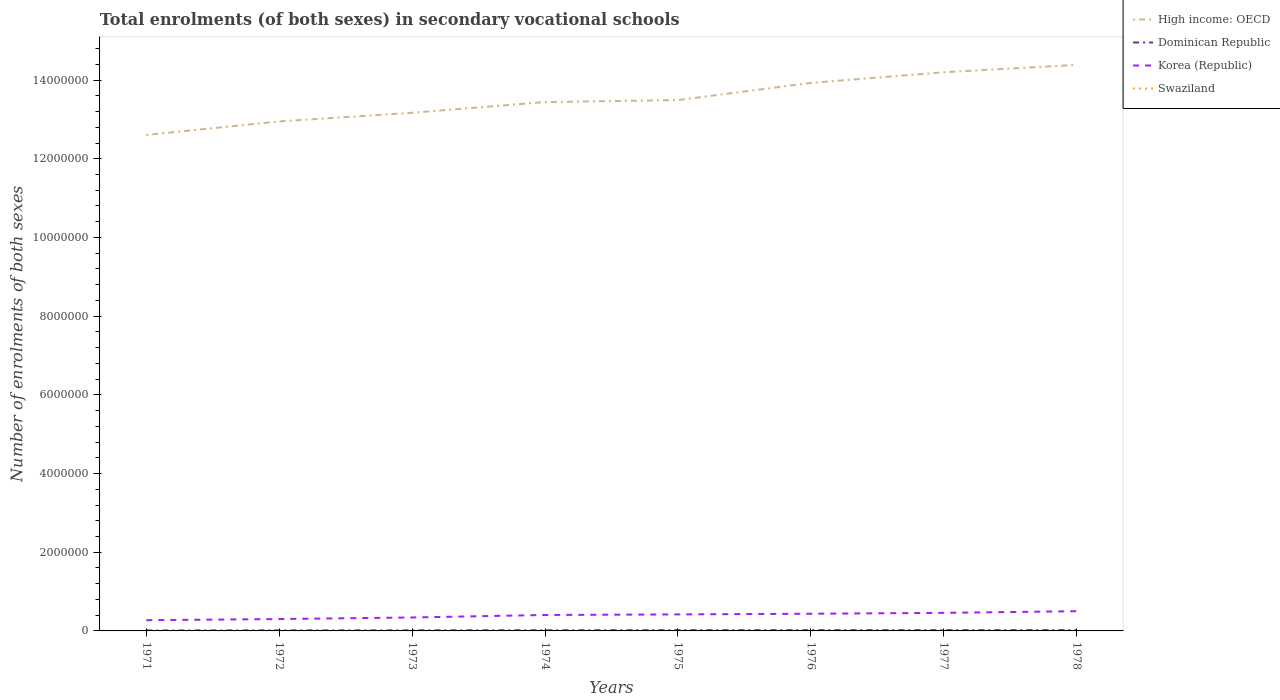Does the line corresponding to High income: OECD intersect with the line corresponding to Korea (Republic)?
Make the answer very short. No. Across all years, what is the maximum number of enrolments in secondary schools in Dominican Republic?
Your response must be concise. 1.26e+04. In which year was the number of enrolments in secondary schools in Swaziland maximum?
Offer a very short reply. 1977. What is the total number of enrolments in secondary schools in High income: OECD in the graph?
Give a very brief answer. -1.88e+05. What is the difference between the highest and the second highest number of enrolments in secondary schools in Dominican Republic?
Your answer should be compact. 8672. How many lines are there?
Offer a very short reply. 4. What is the difference between two consecutive major ticks on the Y-axis?
Your response must be concise. 2.00e+06. Does the graph contain any zero values?
Provide a succinct answer. No. Does the graph contain grids?
Your answer should be very brief. No. How many legend labels are there?
Keep it short and to the point. 4. How are the legend labels stacked?
Ensure brevity in your answer.  Vertical. What is the title of the graph?
Offer a terse response. Total enrolments (of both sexes) in secondary vocational schools. What is the label or title of the X-axis?
Keep it short and to the point. Years. What is the label or title of the Y-axis?
Make the answer very short. Number of enrolments of both sexes. What is the Number of enrolments of both sexes in High income: OECD in 1971?
Keep it short and to the point. 1.26e+07. What is the Number of enrolments of both sexes in Dominican Republic in 1971?
Your answer should be very brief. 1.26e+04. What is the Number of enrolments of both sexes in Korea (Republic) in 1971?
Offer a terse response. 2.73e+05. What is the Number of enrolments of both sexes in Swaziland in 1971?
Keep it short and to the point. 474. What is the Number of enrolments of both sexes of High income: OECD in 1972?
Offer a very short reply. 1.29e+07. What is the Number of enrolments of both sexes of Dominican Republic in 1972?
Give a very brief answer. 1.43e+04. What is the Number of enrolments of both sexes in Korea (Republic) in 1972?
Provide a short and direct response. 3.02e+05. What is the Number of enrolments of both sexes of Swaziland in 1972?
Provide a succinct answer. 538. What is the Number of enrolments of both sexes in High income: OECD in 1973?
Offer a very short reply. 1.32e+07. What is the Number of enrolments of both sexes in Dominican Republic in 1973?
Your answer should be very brief. 1.47e+04. What is the Number of enrolments of both sexes in Korea (Republic) in 1973?
Ensure brevity in your answer.  3.42e+05. What is the Number of enrolments of both sexes in Swaziland in 1973?
Ensure brevity in your answer.  584. What is the Number of enrolments of both sexes of High income: OECD in 1974?
Give a very brief answer. 1.34e+07. What is the Number of enrolments of both sexes in Dominican Republic in 1974?
Offer a terse response. 1.74e+04. What is the Number of enrolments of both sexes in Korea (Republic) in 1974?
Ensure brevity in your answer.  4.05e+05. What is the Number of enrolments of both sexes in Swaziland in 1974?
Keep it short and to the point. 663. What is the Number of enrolments of both sexes of High income: OECD in 1975?
Make the answer very short. 1.35e+07. What is the Number of enrolments of both sexes in Dominican Republic in 1975?
Your answer should be very brief. 1.99e+04. What is the Number of enrolments of both sexes in Korea (Republic) in 1975?
Offer a terse response. 4.20e+05. What is the Number of enrolments of both sexes in Swaziland in 1975?
Make the answer very short. 649. What is the Number of enrolments of both sexes of High income: OECD in 1976?
Make the answer very short. 1.39e+07. What is the Number of enrolments of both sexes of Dominican Republic in 1976?
Your response must be concise. 2.07e+04. What is the Number of enrolments of both sexes of Korea (Republic) in 1976?
Offer a terse response. 4.37e+05. What is the Number of enrolments of both sexes in Swaziland in 1976?
Your answer should be very brief. 472. What is the Number of enrolments of both sexes in High income: OECD in 1977?
Make the answer very short. 1.42e+07. What is the Number of enrolments of both sexes in Dominican Republic in 1977?
Your answer should be very brief. 2.11e+04. What is the Number of enrolments of both sexes of Korea (Republic) in 1977?
Ensure brevity in your answer.  4.59e+05. What is the Number of enrolments of both sexes in Swaziland in 1977?
Offer a terse response. 403. What is the Number of enrolments of both sexes of High income: OECD in 1978?
Your answer should be compact. 1.44e+07. What is the Number of enrolments of both sexes in Dominican Republic in 1978?
Make the answer very short. 2.13e+04. What is the Number of enrolments of both sexes of Korea (Republic) in 1978?
Provide a succinct answer. 5.01e+05. What is the Number of enrolments of both sexes in Swaziland in 1978?
Make the answer very short. 406. Across all years, what is the maximum Number of enrolments of both sexes in High income: OECD?
Provide a short and direct response. 1.44e+07. Across all years, what is the maximum Number of enrolments of both sexes in Dominican Republic?
Your answer should be very brief. 2.13e+04. Across all years, what is the maximum Number of enrolments of both sexes in Korea (Republic)?
Offer a terse response. 5.01e+05. Across all years, what is the maximum Number of enrolments of both sexes of Swaziland?
Ensure brevity in your answer.  663. Across all years, what is the minimum Number of enrolments of both sexes in High income: OECD?
Your answer should be very brief. 1.26e+07. Across all years, what is the minimum Number of enrolments of both sexes in Dominican Republic?
Your response must be concise. 1.26e+04. Across all years, what is the minimum Number of enrolments of both sexes of Korea (Republic)?
Provide a short and direct response. 2.73e+05. Across all years, what is the minimum Number of enrolments of both sexes of Swaziland?
Offer a terse response. 403. What is the total Number of enrolments of both sexes in High income: OECD in the graph?
Keep it short and to the point. 1.08e+08. What is the total Number of enrolments of both sexes of Dominican Republic in the graph?
Provide a short and direct response. 1.42e+05. What is the total Number of enrolments of both sexes in Korea (Republic) in the graph?
Ensure brevity in your answer.  3.14e+06. What is the total Number of enrolments of both sexes in Swaziland in the graph?
Your answer should be compact. 4189. What is the difference between the Number of enrolments of both sexes of High income: OECD in 1971 and that in 1972?
Your response must be concise. -3.44e+05. What is the difference between the Number of enrolments of both sexes of Dominican Republic in 1971 and that in 1972?
Ensure brevity in your answer.  -1627. What is the difference between the Number of enrolments of both sexes of Korea (Republic) in 1971 and that in 1972?
Your response must be concise. -2.92e+04. What is the difference between the Number of enrolments of both sexes in Swaziland in 1971 and that in 1972?
Your answer should be very brief. -64. What is the difference between the Number of enrolments of both sexes of High income: OECD in 1971 and that in 1973?
Your answer should be very brief. -5.64e+05. What is the difference between the Number of enrolments of both sexes in Dominican Republic in 1971 and that in 1973?
Provide a succinct answer. -2021. What is the difference between the Number of enrolments of both sexes of Korea (Republic) in 1971 and that in 1973?
Offer a terse response. -6.92e+04. What is the difference between the Number of enrolments of both sexes of Swaziland in 1971 and that in 1973?
Offer a very short reply. -110. What is the difference between the Number of enrolments of both sexes in High income: OECD in 1971 and that in 1974?
Offer a very short reply. -8.36e+05. What is the difference between the Number of enrolments of both sexes in Dominican Republic in 1971 and that in 1974?
Give a very brief answer. -4732. What is the difference between the Number of enrolments of both sexes of Korea (Republic) in 1971 and that in 1974?
Offer a very short reply. -1.32e+05. What is the difference between the Number of enrolments of both sexes of Swaziland in 1971 and that in 1974?
Give a very brief answer. -189. What is the difference between the Number of enrolments of both sexes in High income: OECD in 1971 and that in 1975?
Ensure brevity in your answer.  -8.86e+05. What is the difference between the Number of enrolments of both sexes of Dominican Republic in 1971 and that in 1975?
Your answer should be very brief. -7251. What is the difference between the Number of enrolments of both sexes in Korea (Republic) in 1971 and that in 1975?
Give a very brief answer. -1.47e+05. What is the difference between the Number of enrolments of both sexes in Swaziland in 1971 and that in 1975?
Offer a very short reply. -175. What is the difference between the Number of enrolments of both sexes in High income: OECD in 1971 and that in 1976?
Make the answer very short. -1.32e+06. What is the difference between the Number of enrolments of both sexes in Dominican Republic in 1971 and that in 1976?
Provide a succinct answer. -8064. What is the difference between the Number of enrolments of both sexes of Korea (Republic) in 1971 and that in 1976?
Ensure brevity in your answer.  -1.64e+05. What is the difference between the Number of enrolments of both sexes in Swaziland in 1971 and that in 1976?
Your answer should be compact. 2. What is the difference between the Number of enrolments of both sexes of High income: OECD in 1971 and that in 1977?
Give a very brief answer. -1.59e+06. What is the difference between the Number of enrolments of both sexes of Dominican Republic in 1971 and that in 1977?
Give a very brief answer. -8474. What is the difference between the Number of enrolments of both sexes of Korea (Republic) in 1971 and that in 1977?
Offer a very short reply. -1.86e+05. What is the difference between the Number of enrolments of both sexes in Swaziland in 1971 and that in 1977?
Your response must be concise. 71. What is the difference between the Number of enrolments of both sexes of High income: OECD in 1971 and that in 1978?
Your answer should be compact. -1.78e+06. What is the difference between the Number of enrolments of both sexes of Dominican Republic in 1971 and that in 1978?
Offer a very short reply. -8672. What is the difference between the Number of enrolments of both sexes in Korea (Republic) in 1971 and that in 1978?
Offer a very short reply. -2.28e+05. What is the difference between the Number of enrolments of both sexes in Swaziland in 1971 and that in 1978?
Provide a succinct answer. 68. What is the difference between the Number of enrolments of both sexes in High income: OECD in 1972 and that in 1973?
Offer a very short reply. -2.20e+05. What is the difference between the Number of enrolments of both sexes in Dominican Republic in 1972 and that in 1973?
Ensure brevity in your answer.  -394. What is the difference between the Number of enrolments of both sexes in Korea (Republic) in 1972 and that in 1973?
Provide a short and direct response. -4.00e+04. What is the difference between the Number of enrolments of both sexes of Swaziland in 1972 and that in 1973?
Keep it short and to the point. -46. What is the difference between the Number of enrolments of both sexes of High income: OECD in 1972 and that in 1974?
Your response must be concise. -4.92e+05. What is the difference between the Number of enrolments of both sexes of Dominican Republic in 1972 and that in 1974?
Provide a succinct answer. -3105. What is the difference between the Number of enrolments of both sexes in Korea (Republic) in 1972 and that in 1974?
Your response must be concise. -1.03e+05. What is the difference between the Number of enrolments of both sexes in Swaziland in 1972 and that in 1974?
Your answer should be very brief. -125. What is the difference between the Number of enrolments of both sexes of High income: OECD in 1972 and that in 1975?
Keep it short and to the point. -5.42e+05. What is the difference between the Number of enrolments of both sexes in Dominican Republic in 1972 and that in 1975?
Offer a terse response. -5624. What is the difference between the Number of enrolments of both sexes of Korea (Republic) in 1972 and that in 1975?
Provide a short and direct response. -1.18e+05. What is the difference between the Number of enrolments of both sexes of Swaziland in 1972 and that in 1975?
Your response must be concise. -111. What is the difference between the Number of enrolments of both sexes of High income: OECD in 1972 and that in 1976?
Provide a short and direct response. -9.78e+05. What is the difference between the Number of enrolments of both sexes of Dominican Republic in 1972 and that in 1976?
Provide a short and direct response. -6437. What is the difference between the Number of enrolments of both sexes in Korea (Republic) in 1972 and that in 1976?
Ensure brevity in your answer.  -1.35e+05. What is the difference between the Number of enrolments of both sexes in High income: OECD in 1972 and that in 1977?
Your response must be concise. -1.25e+06. What is the difference between the Number of enrolments of both sexes of Dominican Republic in 1972 and that in 1977?
Your answer should be compact. -6847. What is the difference between the Number of enrolments of both sexes in Korea (Republic) in 1972 and that in 1977?
Offer a very short reply. -1.57e+05. What is the difference between the Number of enrolments of both sexes of Swaziland in 1972 and that in 1977?
Provide a short and direct response. 135. What is the difference between the Number of enrolments of both sexes in High income: OECD in 1972 and that in 1978?
Ensure brevity in your answer.  -1.44e+06. What is the difference between the Number of enrolments of both sexes in Dominican Republic in 1972 and that in 1978?
Make the answer very short. -7045. What is the difference between the Number of enrolments of both sexes of Korea (Republic) in 1972 and that in 1978?
Provide a succinct answer. -1.99e+05. What is the difference between the Number of enrolments of both sexes of Swaziland in 1972 and that in 1978?
Your answer should be compact. 132. What is the difference between the Number of enrolments of both sexes of High income: OECD in 1973 and that in 1974?
Keep it short and to the point. -2.72e+05. What is the difference between the Number of enrolments of both sexes in Dominican Republic in 1973 and that in 1974?
Provide a succinct answer. -2711. What is the difference between the Number of enrolments of both sexes in Korea (Republic) in 1973 and that in 1974?
Make the answer very short. -6.31e+04. What is the difference between the Number of enrolments of both sexes in Swaziland in 1973 and that in 1974?
Offer a terse response. -79. What is the difference between the Number of enrolments of both sexes in High income: OECD in 1973 and that in 1975?
Provide a short and direct response. -3.22e+05. What is the difference between the Number of enrolments of both sexes of Dominican Republic in 1973 and that in 1975?
Ensure brevity in your answer.  -5230. What is the difference between the Number of enrolments of both sexes in Korea (Republic) in 1973 and that in 1975?
Your answer should be compact. -7.79e+04. What is the difference between the Number of enrolments of both sexes in Swaziland in 1973 and that in 1975?
Make the answer very short. -65. What is the difference between the Number of enrolments of both sexes in High income: OECD in 1973 and that in 1976?
Provide a succinct answer. -7.59e+05. What is the difference between the Number of enrolments of both sexes in Dominican Republic in 1973 and that in 1976?
Provide a succinct answer. -6043. What is the difference between the Number of enrolments of both sexes in Korea (Republic) in 1973 and that in 1976?
Your answer should be very brief. -9.46e+04. What is the difference between the Number of enrolments of both sexes in Swaziland in 1973 and that in 1976?
Provide a succinct answer. 112. What is the difference between the Number of enrolments of both sexes in High income: OECD in 1973 and that in 1977?
Your answer should be compact. -1.03e+06. What is the difference between the Number of enrolments of both sexes of Dominican Republic in 1973 and that in 1977?
Ensure brevity in your answer.  -6453. What is the difference between the Number of enrolments of both sexes in Korea (Republic) in 1973 and that in 1977?
Make the answer very short. -1.17e+05. What is the difference between the Number of enrolments of both sexes of Swaziland in 1973 and that in 1977?
Your answer should be compact. 181. What is the difference between the Number of enrolments of both sexes in High income: OECD in 1973 and that in 1978?
Your answer should be compact. -1.22e+06. What is the difference between the Number of enrolments of both sexes of Dominican Republic in 1973 and that in 1978?
Ensure brevity in your answer.  -6651. What is the difference between the Number of enrolments of both sexes of Korea (Republic) in 1973 and that in 1978?
Keep it short and to the point. -1.59e+05. What is the difference between the Number of enrolments of both sexes of Swaziland in 1973 and that in 1978?
Ensure brevity in your answer.  178. What is the difference between the Number of enrolments of both sexes of High income: OECD in 1974 and that in 1975?
Your response must be concise. -5.01e+04. What is the difference between the Number of enrolments of both sexes of Dominican Republic in 1974 and that in 1975?
Provide a short and direct response. -2519. What is the difference between the Number of enrolments of both sexes in Korea (Republic) in 1974 and that in 1975?
Your answer should be compact. -1.47e+04. What is the difference between the Number of enrolments of both sexes of High income: OECD in 1974 and that in 1976?
Keep it short and to the point. -4.86e+05. What is the difference between the Number of enrolments of both sexes in Dominican Republic in 1974 and that in 1976?
Your answer should be compact. -3332. What is the difference between the Number of enrolments of both sexes in Korea (Republic) in 1974 and that in 1976?
Your answer should be compact. -3.15e+04. What is the difference between the Number of enrolments of both sexes in Swaziland in 1974 and that in 1976?
Your answer should be very brief. 191. What is the difference between the Number of enrolments of both sexes of High income: OECD in 1974 and that in 1977?
Provide a short and direct response. -7.57e+05. What is the difference between the Number of enrolments of both sexes in Dominican Republic in 1974 and that in 1977?
Offer a very short reply. -3742. What is the difference between the Number of enrolments of both sexes of Korea (Republic) in 1974 and that in 1977?
Offer a terse response. -5.41e+04. What is the difference between the Number of enrolments of both sexes of Swaziland in 1974 and that in 1977?
Provide a short and direct response. 260. What is the difference between the Number of enrolments of both sexes of High income: OECD in 1974 and that in 1978?
Keep it short and to the point. -9.45e+05. What is the difference between the Number of enrolments of both sexes in Dominican Republic in 1974 and that in 1978?
Keep it short and to the point. -3940. What is the difference between the Number of enrolments of both sexes in Korea (Republic) in 1974 and that in 1978?
Provide a short and direct response. -9.62e+04. What is the difference between the Number of enrolments of both sexes in Swaziland in 1974 and that in 1978?
Offer a terse response. 257. What is the difference between the Number of enrolments of both sexes of High income: OECD in 1975 and that in 1976?
Keep it short and to the point. -4.36e+05. What is the difference between the Number of enrolments of both sexes in Dominican Republic in 1975 and that in 1976?
Your answer should be compact. -813. What is the difference between the Number of enrolments of both sexes of Korea (Republic) in 1975 and that in 1976?
Provide a succinct answer. -1.67e+04. What is the difference between the Number of enrolments of both sexes of Swaziland in 1975 and that in 1976?
Ensure brevity in your answer.  177. What is the difference between the Number of enrolments of both sexes of High income: OECD in 1975 and that in 1977?
Provide a succinct answer. -7.07e+05. What is the difference between the Number of enrolments of both sexes in Dominican Republic in 1975 and that in 1977?
Provide a succinct answer. -1223. What is the difference between the Number of enrolments of both sexes of Korea (Republic) in 1975 and that in 1977?
Make the answer very short. -3.93e+04. What is the difference between the Number of enrolments of both sexes in Swaziland in 1975 and that in 1977?
Provide a succinct answer. 246. What is the difference between the Number of enrolments of both sexes of High income: OECD in 1975 and that in 1978?
Ensure brevity in your answer.  -8.95e+05. What is the difference between the Number of enrolments of both sexes in Dominican Republic in 1975 and that in 1978?
Offer a very short reply. -1421. What is the difference between the Number of enrolments of both sexes in Korea (Republic) in 1975 and that in 1978?
Ensure brevity in your answer.  -8.14e+04. What is the difference between the Number of enrolments of both sexes in Swaziland in 1975 and that in 1978?
Ensure brevity in your answer.  243. What is the difference between the Number of enrolments of both sexes of High income: OECD in 1976 and that in 1977?
Ensure brevity in your answer.  -2.71e+05. What is the difference between the Number of enrolments of both sexes in Dominican Republic in 1976 and that in 1977?
Offer a terse response. -410. What is the difference between the Number of enrolments of both sexes in Korea (Republic) in 1976 and that in 1977?
Provide a short and direct response. -2.26e+04. What is the difference between the Number of enrolments of both sexes in Swaziland in 1976 and that in 1977?
Provide a short and direct response. 69. What is the difference between the Number of enrolments of both sexes in High income: OECD in 1976 and that in 1978?
Your answer should be compact. -4.59e+05. What is the difference between the Number of enrolments of both sexes of Dominican Republic in 1976 and that in 1978?
Your answer should be compact. -608. What is the difference between the Number of enrolments of both sexes of Korea (Republic) in 1976 and that in 1978?
Keep it short and to the point. -6.47e+04. What is the difference between the Number of enrolments of both sexes in Swaziland in 1976 and that in 1978?
Your answer should be very brief. 66. What is the difference between the Number of enrolments of both sexes in High income: OECD in 1977 and that in 1978?
Your response must be concise. -1.88e+05. What is the difference between the Number of enrolments of both sexes of Dominican Republic in 1977 and that in 1978?
Provide a short and direct response. -198. What is the difference between the Number of enrolments of both sexes in Korea (Republic) in 1977 and that in 1978?
Offer a very short reply. -4.21e+04. What is the difference between the Number of enrolments of both sexes of Swaziland in 1977 and that in 1978?
Provide a short and direct response. -3. What is the difference between the Number of enrolments of both sexes of High income: OECD in 1971 and the Number of enrolments of both sexes of Dominican Republic in 1972?
Offer a very short reply. 1.26e+07. What is the difference between the Number of enrolments of both sexes in High income: OECD in 1971 and the Number of enrolments of both sexes in Korea (Republic) in 1972?
Give a very brief answer. 1.23e+07. What is the difference between the Number of enrolments of both sexes of High income: OECD in 1971 and the Number of enrolments of both sexes of Swaziland in 1972?
Give a very brief answer. 1.26e+07. What is the difference between the Number of enrolments of both sexes in Dominican Republic in 1971 and the Number of enrolments of both sexes in Korea (Republic) in 1972?
Offer a very short reply. -2.89e+05. What is the difference between the Number of enrolments of both sexes of Dominican Republic in 1971 and the Number of enrolments of both sexes of Swaziland in 1972?
Your answer should be very brief. 1.21e+04. What is the difference between the Number of enrolments of both sexes of Korea (Republic) in 1971 and the Number of enrolments of both sexes of Swaziland in 1972?
Offer a terse response. 2.72e+05. What is the difference between the Number of enrolments of both sexes of High income: OECD in 1971 and the Number of enrolments of both sexes of Dominican Republic in 1973?
Make the answer very short. 1.26e+07. What is the difference between the Number of enrolments of both sexes of High income: OECD in 1971 and the Number of enrolments of both sexes of Korea (Republic) in 1973?
Provide a short and direct response. 1.23e+07. What is the difference between the Number of enrolments of both sexes in High income: OECD in 1971 and the Number of enrolments of both sexes in Swaziland in 1973?
Provide a succinct answer. 1.26e+07. What is the difference between the Number of enrolments of both sexes in Dominican Republic in 1971 and the Number of enrolments of both sexes in Korea (Republic) in 1973?
Your answer should be compact. -3.29e+05. What is the difference between the Number of enrolments of both sexes in Dominican Republic in 1971 and the Number of enrolments of both sexes in Swaziland in 1973?
Give a very brief answer. 1.21e+04. What is the difference between the Number of enrolments of both sexes in Korea (Republic) in 1971 and the Number of enrolments of both sexes in Swaziland in 1973?
Your response must be concise. 2.72e+05. What is the difference between the Number of enrolments of both sexes of High income: OECD in 1971 and the Number of enrolments of both sexes of Dominican Republic in 1974?
Keep it short and to the point. 1.26e+07. What is the difference between the Number of enrolments of both sexes in High income: OECD in 1971 and the Number of enrolments of both sexes in Korea (Republic) in 1974?
Provide a succinct answer. 1.22e+07. What is the difference between the Number of enrolments of both sexes of High income: OECD in 1971 and the Number of enrolments of both sexes of Swaziland in 1974?
Your answer should be very brief. 1.26e+07. What is the difference between the Number of enrolments of both sexes of Dominican Republic in 1971 and the Number of enrolments of both sexes of Korea (Republic) in 1974?
Offer a very short reply. -3.92e+05. What is the difference between the Number of enrolments of both sexes in Dominican Republic in 1971 and the Number of enrolments of both sexes in Swaziland in 1974?
Make the answer very short. 1.20e+04. What is the difference between the Number of enrolments of both sexes in Korea (Republic) in 1971 and the Number of enrolments of both sexes in Swaziland in 1974?
Give a very brief answer. 2.72e+05. What is the difference between the Number of enrolments of both sexes of High income: OECD in 1971 and the Number of enrolments of both sexes of Dominican Republic in 1975?
Your answer should be very brief. 1.26e+07. What is the difference between the Number of enrolments of both sexes of High income: OECD in 1971 and the Number of enrolments of both sexes of Korea (Republic) in 1975?
Your answer should be very brief. 1.22e+07. What is the difference between the Number of enrolments of both sexes of High income: OECD in 1971 and the Number of enrolments of both sexes of Swaziland in 1975?
Make the answer very short. 1.26e+07. What is the difference between the Number of enrolments of both sexes in Dominican Republic in 1971 and the Number of enrolments of both sexes in Korea (Republic) in 1975?
Make the answer very short. -4.07e+05. What is the difference between the Number of enrolments of both sexes in Dominican Republic in 1971 and the Number of enrolments of both sexes in Swaziland in 1975?
Your answer should be compact. 1.20e+04. What is the difference between the Number of enrolments of both sexes of Korea (Republic) in 1971 and the Number of enrolments of both sexes of Swaziland in 1975?
Ensure brevity in your answer.  2.72e+05. What is the difference between the Number of enrolments of both sexes in High income: OECD in 1971 and the Number of enrolments of both sexes in Dominican Republic in 1976?
Ensure brevity in your answer.  1.26e+07. What is the difference between the Number of enrolments of both sexes of High income: OECD in 1971 and the Number of enrolments of both sexes of Korea (Republic) in 1976?
Your response must be concise. 1.22e+07. What is the difference between the Number of enrolments of both sexes in High income: OECD in 1971 and the Number of enrolments of both sexes in Swaziland in 1976?
Your response must be concise. 1.26e+07. What is the difference between the Number of enrolments of both sexes in Dominican Republic in 1971 and the Number of enrolments of both sexes in Korea (Republic) in 1976?
Give a very brief answer. -4.24e+05. What is the difference between the Number of enrolments of both sexes in Dominican Republic in 1971 and the Number of enrolments of both sexes in Swaziland in 1976?
Make the answer very short. 1.22e+04. What is the difference between the Number of enrolments of both sexes of Korea (Republic) in 1971 and the Number of enrolments of both sexes of Swaziland in 1976?
Give a very brief answer. 2.72e+05. What is the difference between the Number of enrolments of both sexes in High income: OECD in 1971 and the Number of enrolments of both sexes in Dominican Republic in 1977?
Your answer should be compact. 1.26e+07. What is the difference between the Number of enrolments of both sexes of High income: OECD in 1971 and the Number of enrolments of both sexes of Korea (Republic) in 1977?
Offer a very short reply. 1.21e+07. What is the difference between the Number of enrolments of both sexes of High income: OECD in 1971 and the Number of enrolments of both sexes of Swaziland in 1977?
Your response must be concise. 1.26e+07. What is the difference between the Number of enrolments of both sexes of Dominican Republic in 1971 and the Number of enrolments of both sexes of Korea (Republic) in 1977?
Your answer should be compact. -4.46e+05. What is the difference between the Number of enrolments of both sexes in Dominican Republic in 1971 and the Number of enrolments of both sexes in Swaziland in 1977?
Keep it short and to the point. 1.22e+04. What is the difference between the Number of enrolments of both sexes in Korea (Republic) in 1971 and the Number of enrolments of both sexes in Swaziland in 1977?
Your answer should be very brief. 2.72e+05. What is the difference between the Number of enrolments of both sexes in High income: OECD in 1971 and the Number of enrolments of both sexes in Dominican Republic in 1978?
Your response must be concise. 1.26e+07. What is the difference between the Number of enrolments of both sexes in High income: OECD in 1971 and the Number of enrolments of both sexes in Korea (Republic) in 1978?
Offer a terse response. 1.21e+07. What is the difference between the Number of enrolments of both sexes of High income: OECD in 1971 and the Number of enrolments of both sexes of Swaziland in 1978?
Provide a short and direct response. 1.26e+07. What is the difference between the Number of enrolments of both sexes of Dominican Republic in 1971 and the Number of enrolments of both sexes of Korea (Republic) in 1978?
Your answer should be compact. -4.89e+05. What is the difference between the Number of enrolments of both sexes of Dominican Republic in 1971 and the Number of enrolments of both sexes of Swaziland in 1978?
Offer a terse response. 1.22e+04. What is the difference between the Number of enrolments of both sexes of Korea (Republic) in 1971 and the Number of enrolments of both sexes of Swaziland in 1978?
Give a very brief answer. 2.72e+05. What is the difference between the Number of enrolments of both sexes in High income: OECD in 1972 and the Number of enrolments of both sexes in Dominican Republic in 1973?
Offer a very short reply. 1.29e+07. What is the difference between the Number of enrolments of both sexes in High income: OECD in 1972 and the Number of enrolments of both sexes in Korea (Republic) in 1973?
Offer a very short reply. 1.26e+07. What is the difference between the Number of enrolments of both sexes in High income: OECD in 1972 and the Number of enrolments of both sexes in Swaziland in 1973?
Your answer should be compact. 1.29e+07. What is the difference between the Number of enrolments of both sexes of Dominican Republic in 1972 and the Number of enrolments of both sexes of Korea (Republic) in 1973?
Ensure brevity in your answer.  -3.28e+05. What is the difference between the Number of enrolments of both sexes of Dominican Republic in 1972 and the Number of enrolments of both sexes of Swaziland in 1973?
Offer a very short reply. 1.37e+04. What is the difference between the Number of enrolments of both sexes in Korea (Republic) in 1972 and the Number of enrolments of both sexes in Swaziland in 1973?
Offer a very short reply. 3.01e+05. What is the difference between the Number of enrolments of both sexes in High income: OECD in 1972 and the Number of enrolments of both sexes in Dominican Republic in 1974?
Your answer should be very brief. 1.29e+07. What is the difference between the Number of enrolments of both sexes of High income: OECD in 1972 and the Number of enrolments of both sexes of Korea (Republic) in 1974?
Your response must be concise. 1.25e+07. What is the difference between the Number of enrolments of both sexes of High income: OECD in 1972 and the Number of enrolments of both sexes of Swaziland in 1974?
Keep it short and to the point. 1.29e+07. What is the difference between the Number of enrolments of both sexes in Dominican Republic in 1972 and the Number of enrolments of both sexes in Korea (Republic) in 1974?
Keep it short and to the point. -3.91e+05. What is the difference between the Number of enrolments of both sexes of Dominican Republic in 1972 and the Number of enrolments of both sexes of Swaziland in 1974?
Give a very brief answer. 1.36e+04. What is the difference between the Number of enrolments of both sexes in Korea (Republic) in 1972 and the Number of enrolments of both sexes in Swaziland in 1974?
Provide a succinct answer. 3.01e+05. What is the difference between the Number of enrolments of both sexes in High income: OECD in 1972 and the Number of enrolments of both sexes in Dominican Republic in 1975?
Give a very brief answer. 1.29e+07. What is the difference between the Number of enrolments of both sexes of High income: OECD in 1972 and the Number of enrolments of both sexes of Korea (Republic) in 1975?
Your response must be concise. 1.25e+07. What is the difference between the Number of enrolments of both sexes of High income: OECD in 1972 and the Number of enrolments of both sexes of Swaziland in 1975?
Your answer should be compact. 1.29e+07. What is the difference between the Number of enrolments of both sexes in Dominican Republic in 1972 and the Number of enrolments of both sexes in Korea (Republic) in 1975?
Provide a short and direct response. -4.06e+05. What is the difference between the Number of enrolments of both sexes of Dominican Republic in 1972 and the Number of enrolments of both sexes of Swaziland in 1975?
Your answer should be very brief. 1.36e+04. What is the difference between the Number of enrolments of both sexes of Korea (Republic) in 1972 and the Number of enrolments of both sexes of Swaziland in 1975?
Your answer should be compact. 3.01e+05. What is the difference between the Number of enrolments of both sexes of High income: OECD in 1972 and the Number of enrolments of both sexes of Dominican Republic in 1976?
Provide a succinct answer. 1.29e+07. What is the difference between the Number of enrolments of both sexes of High income: OECD in 1972 and the Number of enrolments of both sexes of Korea (Republic) in 1976?
Make the answer very short. 1.25e+07. What is the difference between the Number of enrolments of both sexes of High income: OECD in 1972 and the Number of enrolments of both sexes of Swaziland in 1976?
Your answer should be compact. 1.29e+07. What is the difference between the Number of enrolments of both sexes in Dominican Republic in 1972 and the Number of enrolments of both sexes in Korea (Republic) in 1976?
Your response must be concise. -4.22e+05. What is the difference between the Number of enrolments of both sexes of Dominican Republic in 1972 and the Number of enrolments of both sexes of Swaziland in 1976?
Offer a terse response. 1.38e+04. What is the difference between the Number of enrolments of both sexes of Korea (Republic) in 1972 and the Number of enrolments of both sexes of Swaziland in 1976?
Keep it short and to the point. 3.01e+05. What is the difference between the Number of enrolments of both sexes of High income: OECD in 1972 and the Number of enrolments of both sexes of Dominican Republic in 1977?
Your answer should be very brief. 1.29e+07. What is the difference between the Number of enrolments of both sexes in High income: OECD in 1972 and the Number of enrolments of both sexes in Korea (Republic) in 1977?
Keep it short and to the point. 1.25e+07. What is the difference between the Number of enrolments of both sexes of High income: OECD in 1972 and the Number of enrolments of both sexes of Swaziland in 1977?
Offer a very short reply. 1.29e+07. What is the difference between the Number of enrolments of both sexes of Dominican Republic in 1972 and the Number of enrolments of both sexes of Korea (Republic) in 1977?
Keep it short and to the point. -4.45e+05. What is the difference between the Number of enrolments of both sexes of Dominican Republic in 1972 and the Number of enrolments of both sexes of Swaziland in 1977?
Keep it short and to the point. 1.39e+04. What is the difference between the Number of enrolments of both sexes in Korea (Republic) in 1972 and the Number of enrolments of both sexes in Swaziland in 1977?
Your answer should be very brief. 3.01e+05. What is the difference between the Number of enrolments of both sexes of High income: OECD in 1972 and the Number of enrolments of both sexes of Dominican Republic in 1978?
Provide a succinct answer. 1.29e+07. What is the difference between the Number of enrolments of both sexes of High income: OECD in 1972 and the Number of enrolments of both sexes of Korea (Republic) in 1978?
Your answer should be very brief. 1.24e+07. What is the difference between the Number of enrolments of both sexes in High income: OECD in 1972 and the Number of enrolments of both sexes in Swaziland in 1978?
Your answer should be compact. 1.29e+07. What is the difference between the Number of enrolments of both sexes in Dominican Republic in 1972 and the Number of enrolments of both sexes in Korea (Republic) in 1978?
Your answer should be very brief. -4.87e+05. What is the difference between the Number of enrolments of both sexes in Dominican Republic in 1972 and the Number of enrolments of both sexes in Swaziland in 1978?
Give a very brief answer. 1.39e+04. What is the difference between the Number of enrolments of both sexes in Korea (Republic) in 1972 and the Number of enrolments of both sexes in Swaziland in 1978?
Keep it short and to the point. 3.01e+05. What is the difference between the Number of enrolments of both sexes of High income: OECD in 1973 and the Number of enrolments of both sexes of Dominican Republic in 1974?
Your response must be concise. 1.32e+07. What is the difference between the Number of enrolments of both sexes in High income: OECD in 1973 and the Number of enrolments of both sexes in Korea (Republic) in 1974?
Your response must be concise. 1.28e+07. What is the difference between the Number of enrolments of both sexes in High income: OECD in 1973 and the Number of enrolments of both sexes in Swaziland in 1974?
Make the answer very short. 1.32e+07. What is the difference between the Number of enrolments of both sexes of Dominican Republic in 1973 and the Number of enrolments of both sexes of Korea (Republic) in 1974?
Keep it short and to the point. -3.90e+05. What is the difference between the Number of enrolments of both sexes in Dominican Republic in 1973 and the Number of enrolments of both sexes in Swaziland in 1974?
Make the answer very short. 1.40e+04. What is the difference between the Number of enrolments of both sexes in Korea (Republic) in 1973 and the Number of enrolments of both sexes in Swaziland in 1974?
Your answer should be very brief. 3.41e+05. What is the difference between the Number of enrolments of both sexes of High income: OECD in 1973 and the Number of enrolments of both sexes of Dominican Republic in 1975?
Offer a terse response. 1.31e+07. What is the difference between the Number of enrolments of both sexes of High income: OECD in 1973 and the Number of enrolments of both sexes of Korea (Republic) in 1975?
Offer a very short reply. 1.27e+07. What is the difference between the Number of enrolments of both sexes in High income: OECD in 1973 and the Number of enrolments of both sexes in Swaziland in 1975?
Offer a terse response. 1.32e+07. What is the difference between the Number of enrolments of both sexes in Dominican Republic in 1973 and the Number of enrolments of both sexes in Korea (Republic) in 1975?
Ensure brevity in your answer.  -4.05e+05. What is the difference between the Number of enrolments of both sexes of Dominican Republic in 1973 and the Number of enrolments of both sexes of Swaziland in 1975?
Provide a short and direct response. 1.40e+04. What is the difference between the Number of enrolments of both sexes of Korea (Republic) in 1973 and the Number of enrolments of both sexes of Swaziland in 1975?
Your answer should be compact. 3.41e+05. What is the difference between the Number of enrolments of both sexes of High income: OECD in 1973 and the Number of enrolments of both sexes of Dominican Republic in 1976?
Give a very brief answer. 1.31e+07. What is the difference between the Number of enrolments of both sexes in High income: OECD in 1973 and the Number of enrolments of both sexes in Korea (Republic) in 1976?
Keep it short and to the point. 1.27e+07. What is the difference between the Number of enrolments of both sexes in High income: OECD in 1973 and the Number of enrolments of both sexes in Swaziland in 1976?
Keep it short and to the point. 1.32e+07. What is the difference between the Number of enrolments of both sexes in Dominican Republic in 1973 and the Number of enrolments of both sexes in Korea (Republic) in 1976?
Keep it short and to the point. -4.22e+05. What is the difference between the Number of enrolments of both sexes of Dominican Republic in 1973 and the Number of enrolments of both sexes of Swaziland in 1976?
Ensure brevity in your answer.  1.42e+04. What is the difference between the Number of enrolments of both sexes in Korea (Republic) in 1973 and the Number of enrolments of both sexes in Swaziland in 1976?
Make the answer very short. 3.41e+05. What is the difference between the Number of enrolments of both sexes in High income: OECD in 1973 and the Number of enrolments of both sexes in Dominican Republic in 1977?
Your answer should be compact. 1.31e+07. What is the difference between the Number of enrolments of both sexes in High income: OECD in 1973 and the Number of enrolments of both sexes in Korea (Republic) in 1977?
Your answer should be very brief. 1.27e+07. What is the difference between the Number of enrolments of both sexes in High income: OECD in 1973 and the Number of enrolments of both sexes in Swaziland in 1977?
Your answer should be compact. 1.32e+07. What is the difference between the Number of enrolments of both sexes in Dominican Republic in 1973 and the Number of enrolments of both sexes in Korea (Republic) in 1977?
Offer a terse response. -4.44e+05. What is the difference between the Number of enrolments of both sexes of Dominican Republic in 1973 and the Number of enrolments of both sexes of Swaziland in 1977?
Your response must be concise. 1.43e+04. What is the difference between the Number of enrolments of both sexes in Korea (Republic) in 1973 and the Number of enrolments of both sexes in Swaziland in 1977?
Provide a short and direct response. 3.42e+05. What is the difference between the Number of enrolments of both sexes in High income: OECD in 1973 and the Number of enrolments of both sexes in Dominican Republic in 1978?
Give a very brief answer. 1.31e+07. What is the difference between the Number of enrolments of both sexes in High income: OECD in 1973 and the Number of enrolments of both sexes in Korea (Republic) in 1978?
Provide a succinct answer. 1.27e+07. What is the difference between the Number of enrolments of both sexes of High income: OECD in 1973 and the Number of enrolments of both sexes of Swaziland in 1978?
Offer a very short reply. 1.32e+07. What is the difference between the Number of enrolments of both sexes of Dominican Republic in 1973 and the Number of enrolments of both sexes of Korea (Republic) in 1978?
Provide a succinct answer. -4.87e+05. What is the difference between the Number of enrolments of both sexes of Dominican Republic in 1973 and the Number of enrolments of both sexes of Swaziland in 1978?
Your answer should be very brief. 1.43e+04. What is the difference between the Number of enrolments of both sexes in Korea (Republic) in 1973 and the Number of enrolments of both sexes in Swaziland in 1978?
Give a very brief answer. 3.42e+05. What is the difference between the Number of enrolments of both sexes of High income: OECD in 1974 and the Number of enrolments of both sexes of Dominican Republic in 1975?
Provide a succinct answer. 1.34e+07. What is the difference between the Number of enrolments of both sexes of High income: OECD in 1974 and the Number of enrolments of both sexes of Korea (Republic) in 1975?
Your answer should be very brief. 1.30e+07. What is the difference between the Number of enrolments of both sexes of High income: OECD in 1974 and the Number of enrolments of both sexes of Swaziland in 1975?
Give a very brief answer. 1.34e+07. What is the difference between the Number of enrolments of both sexes of Dominican Republic in 1974 and the Number of enrolments of both sexes of Korea (Republic) in 1975?
Your answer should be very brief. -4.02e+05. What is the difference between the Number of enrolments of both sexes of Dominican Republic in 1974 and the Number of enrolments of both sexes of Swaziland in 1975?
Your answer should be compact. 1.67e+04. What is the difference between the Number of enrolments of both sexes of Korea (Republic) in 1974 and the Number of enrolments of both sexes of Swaziland in 1975?
Ensure brevity in your answer.  4.04e+05. What is the difference between the Number of enrolments of both sexes in High income: OECD in 1974 and the Number of enrolments of both sexes in Dominican Republic in 1976?
Keep it short and to the point. 1.34e+07. What is the difference between the Number of enrolments of both sexes of High income: OECD in 1974 and the Number of enrolments of both sexes of Korea (Republic) in 1976?
Your response must be concise. 1.30e+07. What is the difference between the Number of enrolments of both sexes in High income: OECD in 1974 and the Number of enrolments of both sexes in Swaziland in 1976?
Make the answer very short. 1.34e+07. What is the difference between the Number of enrolments of both sexes in Dominican Republic in 1974 and the Number of enrolments of both sexes in Korea (Republic) in 1976?
Offer a terse response. -4.19e+05. What is the difference between the Number of enrolments of both sexes in Dominican Republic in 1974 and the Number of enrolments of both sexes in Swaziland in 1976?
Ensure brevity in your answer.  1.69e+04. What is the difference between the Number of enrolments of both sexes in Korea (Republic) in 1974 and the Number of enrolments of both sexes in Swaziland in 1976?
Keep it short and to the point. 4.05e+05. What is the difference between the Number of enrolments of both sexes of High income: OECD in 1974 and the Number of enrolments of both sexes of Dominican Republic in 1977?
Your answer should be very brief. 1.34e+07. What is the difference between the Number of enrolments of both sexes of High income: OECD in 1974 and the Number of enrolments of both sexes of Korea (Republic) in 1977?
Give a very brief answer. 1.30e+07. What is the difference between the Number of enrolments of both sexes in High income: OECD in 1974 and the Number of enrolments of both sexes in Swaziland in 1977?
Your answer should be very brief. 1.34e+07. What is the difference between the Number of enrolments of both sexes of Dominican Republic in 1974 and the Number of enrolments of both sexes of Korea (Republic) in 1977?
Give a very brief answer. -4.42e+05. What is the difference between the Number of enrolments of both sexes of Dominican Republic in 1974 and the Number of enrolments of both sexes of Swaziland in 1977?
Provide a succinct answer. 1.70e+04. What is the difference between the Number of enrolments of both sexes of Korea (Republic) in 1974 and the Number of enrolments of both sexes of Swaziland in 1977?
Provide a succinct answer. 4.05e+05. What is the difference between the Number of enrolments of both sexes of High income: OECD in 1974 and the Number of enrolments of both sexes of Dominican Republic in 1978?
Your answer should be compact. 1.34e+07. What is the difference between the Number of enrolments of both sexes in High income: OECD in 1974 and the Number of enrolments of both sexes in Korea (Republic) in 1978?
Your answer should be compact. 1.29e+07. What is the difference between the Number of enrolments of both sexes of High income: OECD in 1974 and the Number of enrolments of both sexes of Swaziland in 1978?
Make the answer very short. 1.34e+07. What is the difference between the Number of enrolments of both sexes in Dominican Republic in 1974 and the Number of enrolments of both sexes in Korea (Republic) in 1978?
Provide a short and direct response. -4.84e+05. What is the difference between the Number of enrolments of both sexes of Dominican Republic in 1974 and the Number of enrolments of both sexes of Swaziland in 1978?
Your answer should be very brief. 1.70e+04. What is the difference between the Number of enrolments of both sexes of Korea (Republic) in 1974 and the Number of enrolments of both sexes of Swaziland in 1978?
Provide a short and direct response. 4.05e+05. What is the difference between the Number of enrolments of both sexes in High income: OECD in 1975 and the Number of enrolments of both sexes in Dominican Republic in 1976?
Your answer should be compact. 1.35e+07. What is the difference between the Number of enrolments of both sexes in High income: OECD in 1975 and the Number of enrolments of both sexes in Korea (Republic) in 1976?
Offer a terse response. 1.31e+07. What is the difference between the Number of enrolments of both sexes of High income: OECD in 1975 and the Number of enrolments of both sexes of Swaziland in 1976?
Ensure brevity in your answer.  1.35e+07. What is the difference between the Number of enrolments of both sexes in Dominican Republic in 1975 and the Number of enrolments of both sexes in Korea (Republic) in 1976?
Your answer should be very brief. -4.17e+05. What is the difference between the Number of enrolments of both sexes of Dominican Republic in 1975 and the Number of enrolments of both sexes of Swaziland in 1976?
Offer a very short reply. 1.94e+04. What is the difference between the Number of enrolments of both sexes in Korea (Republic) in 1975 and the Number of enrolments of both sexes in Swaziland in 1976?
Make the answer very short. 4.19e+05. What is the difference between the Number of enrolments of both sexes of High income: OECD in 1975 and the Number of enrolments of both sexes of Dominican Republic in 1977?
Provide a short and direct response. 1.35e+07. What is the difference between the Number of enrolments of both sexes of High income: OECD in 1975 and the Number of enrolments of both sexes of Korea (Republic) in 1977?
Your answer should be compact. 1.30e+07. What is the difference between the Number of enrolments of both sexes in High income: OECD in 1975 and the Number of enrolments of both sexes in Swaziland in 1977?
Ensure brevity in your answer.  1.35e+07. What is the difference between the Number of enrolments of both sexes of Dominican Republic in 1975 and the Number of enrolments of both sexes of Korea (Republic) in 1977?
Keep it short and to the point. -4.39e+05. What is the difference between the Number of enrolments of both sexes in Dominican Republic in 1975 and the Number of enrolments of both sexes in Swaziland in 1977?
Ensure brevity in your answer.  1.95e+04. What is the difference between the Number of enrolments of both sexes in Korea (Republic) in 1975 and the Number of enrolments of both sexes in Swaziland in 1977?
Your answer should be very brief. 4.19e+05. What is the difference between the Number of enrolments of both sexes of High income: OECD in 1975 and the Number of enrolments of both sexes of Dominican Republic in 1978?
Provide a short and direct response. 1.35e+07. What is the difference between the Number of enrolments of both sexes of High income: OECD in 1975 and the Number of enrolments of both sexes of Korea (Republic) in 1978?
Provide a short and direct response. 1.30e+07. What is the difference between the Number of enrolments of both sexes in High income: OECD in 1975 and the Number of enrolments of both sexes in Swaziland in 1978?
Give a very brief answer. 1.35e+07. What is the difference between the Number of enrolments of both sexes of Dominican Republic in 1975 and the Number of enrolments of both sexes of Korea (Republic) in 1978?
Your response must be concise. -4.81e+05. What is the difference between the Number of enrolments of both sexes in Dominican Republic in 1975 and the Number of enrolments of both sexes in Swaziland in 1978?
Your answer should be very brief. 1.95e+04. What is the difference between the Number of enrolments of both sexes of Korea (Republic) in 1975 and the Number of enrolments of both sexes of Swaziland in 1978?
Make the answer very short. 4.19e+05. What is the difference between the Number of enrolments of both sexes of High income: OECD in 1976 and the Number of enrolments of both sexes of Dominican Republic in 1977?
Offer a terse response. 1.39e+07. What is the difference between the Number of enrolments of both sexes of High income: OECD in 1976 and the Number of enrolments of both sexes of Korea (Republic) in 1977?
Keep it short and to the point. 1.35e+07. What is the difference between the Number of enrolments of both sexes in High income: OECD in 1976 and the Number of enrolments of both sexes in Swaziland in 1977?
Make the answer very short. 1.39e+07. What is the difference between the Number of enrolments of both sexes in Dominican Republic in 1976 and the Number of enrolments of both sexes in Korea (Republic) in 1977?
Make the answer very short. -4.38e+05. What is the difference between the Number of enrolments of both sexes of Dominican Republic in 1976 and the Number of enrolments of both sexes of Swaziland in 1977?
Provide a short and direct response. 2.03e+04. What is the difference between the Number of enrolments of both sexes of Korea (Republic) in 1976 and the Number of enrolments of both sexes of Swaziland in 1977?
Give a very brief answer. 4.36e+05. What is the difference between the Number of enrolments of both sexes in High income: OECD in 1976 and the Number of enrolments of both sexes in Dominican Republic in 1978?
Keep it short and to the point. 1.39e+07. What is the difference between the Number of enrolments of both sexes in High income: OECD in 1976 and the Number of enrolments of both sexes in Korea (Republic) in 1978?
Your answer should be very brief. 1.34e+07. What is the difference between the Number of enrolments of both sexes in High income: OECD in 1976 and the Number of enrolments of both sexes in Swaziland in 1978?
Your answer should be compact. 1.39e+07. What is the difference between the Number of enrolments of both sexes in Dominican Republic in 1976 and the Number of enrolments of both sexes in Korea (Republic) in 1978?
Your answer should be compact. -4.81e+05. What is the difference between the Number of enrolments of both sexes of Dominican Republic in 1976 and the Number of enrolments of both sexes of Swaziland in 1978?
Make the answer very short. 2.03e+04. What is the difference between the Number of enrolments of both sexes in Korea (Republic) in 1976 and the Number of enrolments of both sexes in Swaziland in 1978?
Ensure brevity in your answer.  4.36e+05. What is the difference between the Number of enrolments of both sexes in High income: OECD in 1977 and the Number of enrolments of both sexes in Dominican Republic in 1978?
Provide a succinct answer. 1.42e+07. What is the difference between the Number of enrolments of both sexes in High income: OECD in 1977 and the Number of enrolments of both sexes in Korea (Republic) in 1978?
Offer a very short reply. 1.37e+07. What is the difference between the Number of enrolments of both sexes of High income: OECD in 1977 and the Number of enrolments of both sexes of Swaziland in 1978?
Provide a short and direct response. 1.42e+07. What is the difference between the Number of enrolments of both sexes in Dominican Republic in 1977 and the Number of enrolments of both sexes in Korea (Republic) in 1978?
Make the answer very short. -4.80e+05. What is the difference between the Number of enrolments of both sexes in Dominican Republic in 1977 and the Number of enrolments of both sexes in Swaziland in 1978?
Your response must be concise. 2.07e+04. What is the difference between the Number of enrolments of both sexes of Korea (Republic) in 1977 and the Number of enrolments of both sexes of Swaziland in 1978?
Your answer should be compact. 4.59e+05. What is the average Number of enrolments of both sexes in High income: OECD per year?
Provide a succinct answer. 1.35e+07. What is the average Number of enrolments of both sexes of Dominican Republic per year?
Ensure brevity in your answer.  1.78e+04. What is the average Number of enrolments of both sexes in Korea (Republic) per year?
Make the answer very short. 3.92e+05. What is the average Number of enrolments of both sexes of Swaziland per year?
Your answer should be compact. 523.62. In the year 1971, what is the difference between the Number of enrolments of both sexes of High income: OECD and Number of enrolments of both sexes of Dominican Republic?
Keep it short and to the point. 1.26e+07. In the year 1971, what is the difference between the Number of enrolments of both sexes in High income: OECD and Number of enrolments of both sexes in Korea (Republic)?
Keep it short and to the point. 1.23e+07. In the year 1971, what is the difference between the Number of enrolments of both sexes in High income: OECD and Number of enrolments of both sexes in Swaziland?
Keep it short and to the point. 1.26e+07. In the year 1971, what is the difference between the Number of enrolments of both sexes in Dominican Republic and Number of enrolments of both sexes in Korea (Republic)?
Provide a succinct answer. -2.60e+05. In the year 1971, what is the difference between the Number of enrolments of both sexes of Dominican Republic and Number of enrolments of both sexes of Swaziland?
Your response must be concise. 1.22e+04. In the year 1971, what is the difference between the Number of enrolments of both sexes of Korea (Republic) and Number of enrolments of both sexes of Swaziland?
Keep it short and to the point. 2.72e+05. In the year 1972, what is the difference between the Number of enrolments of both sexes in High income: OECD and Number of enrolments of both sexes in Dominican Republic?
Give a very brief answer. 1.29e+07. In the year 1972, what is the difference between the Number of enrolments of both sexes of High income: OECD and Number of enrolments of both sexes of Korea (Republic)?
Offer a very short reply. 1.26e+07. In the year 1972, what is the difference between the Number of enrolments of both sexes in High income: OECD and Number of enrolments of both sexes in Swaziland?
Offer a terse response. 1.29e+07. In the year 1972, what is the difference between the Number of enrolments of both sexes in Dominican Republic and Number of enrolments of both sexes in Korea (Republic)?
Offer a terse response. -2.88e+05. In the year 1972, what is the difference between the Number of enrolments of both sexes of Dominican Republic and Number of enrolments of both sexes of Swaziland?
Your response must be concise. 1.37e+04. In the year 1972, what is the difference between the Number of enrolments of both sexes in Korea (Republic) and Number of enrolments of both sexes in Swaziland?
Make the answer very short. 3.01e+05. In the year 1973, what is the difference between the Number of enrolments of both sexes in High income: OECD and Number of enrolments of both sexes in Dominican Republic?
Offer a terse response. 1.32e+07. In the year 1973, what is the difference between the Number of enrolments of both sexes in High income: OECD and Number of enrolments of both sexes in Korea (Republic)?
Make the answer very short. 1.28e+07. In the year 1973, what is the difference between the Number of enrolments of both sexes in High income: OECD and Number of enrolments of both sexes in Swaziland?
Provide a succinct answer. 1.32e+07. In the year 1973, what is the difference between the Number of enrolments of both sexes in Dominican Republic and Number of enrolments of both sexes in Korea (Republic)?
Your answer should be compact. -3.27e+05. In the year 1973, what is the difference between the Number of enrolments of both sexes in Dominican Republic and Number of enrolments of both sexes in Swaziland?
Ensure brevity in your answer.  1.41e+04. In the year 1973, what is the difference between the Number of enrolments of both sexes of Korea (Republic) and Number of enrolments of both sexes of Swaziland?
Provide a succinct answer. 3.41e+05. In the year 1974, what is the difference between the Number of enrolments of both sexes of High income: OECD and Number of enrolments of both sexes of Dominican Republic?
Offer a very short reply. 1.34e+07. In the year 1974, what is the difference between the Number of enrolments of both sexes of High income: OECD and Number of enrolments of both sexes of Korea (Republic)?
Give a very brief answer. 1.30e+07. In the year 1974, what is the difference between the Number of enrolments of both sexes in High income: OECD and Number of enrolments of both sexes in Swaziland?
Provide a short and direct response. 1.34e+07. In the year 1974, what is the difference between the Number of enrolments of both sexes of Dominican Republic and Number of enrolments of both sexes of Korea (Republic)?
Give a very brief answer. -3.88e+05. In the year 1974, what is the difference between the Number of enrolments of both sexes in Dominican Republic and Number of enrolments of both sexes in Swaziland?
Provide a succinct answer. 1.67e+04. In the year 1974, what is the difference between the Number of enrolments of both sexes in Korea (Republic) and Number of enrolments of both sexes in Swaziland?
Ensure brevity in your answer.  4.04e+05. In the year 1975, what is the difference between the Number of enrolments of both sexes of High income: OECD and Number of enrolments of both sexes of Dominican Republic?
Offer a very short reply. 1.35e+07. In the year 1975, what is the difference between the Number of enrolments of both sexes in High income: OECD and Number of enrolments of both sexes in Korea (Republic)?
Keep it short and to the point. 1.31e+07. In the year 1975, what is the difference between the Number of enrolments of both sexes in High income: OECD and Number of enrolments of both sexes in Swaziland?
Make the answer very short. 1.35e+07. In the year 1975, what is the difference between the Number of enrolments of both sexes of Dominican Republic and Number of enrolments of both sexes of Korea (Republic)?
Keep it short and to the point. -4.00e+05. In the year 1975, what is the difference between the Number of enrolments of both sexes of Dominican Republic and Number of enrolments of both sexes of Swaziland?
Your answer should be compact. 1.92e+04. In the year 1975, what is the difference between the Number of enrolments of both sexes of Korea (Republic) and Number of enrolments of both sexes of Swaziland?
Keep it short and to the point. 4.19e+05. In the year 1976, what is the difference between the Number of enrolments of both sexes of High income: OECD and Number of enrolments of both sexes of Dominican Republic?
Offer a very short reply. 1.39e+07. In the year 1976, what is the difference between the Number of enrolments of both sexes in High income: OECD and Number of enrolments of both sexes in Korea (Republic)?
Give a very brief answer. 1.35e+07. In the year 1976, what is the difference between the Number of enrolments of both sexes of High income: OECD and Number of enrolments of both sexes of Swaziland?
Provide a short and direct response. 1.39e+07. In the year 1976, what is the difference between the Number of enrolments of both sexes of Dominican Republic and Number of enrolments of both sexes of Korea (Republic)?
Provide a short and direct response. -4.16e+05. In the year 1976, what is the difference between the Number of enrolments of both sexes of Dominican Republic and Number of enrolments of both sexes of Swaziland?
Give a very brief answer. 2.02e+04. In the year 1976, what is the difference between the Number of enrolments of both sexes in Korea (Republic) and Number of enrolments of both sexes in Swaziland?
Provide a short and direct response. 4.36e+05. In the year 1977, what is the difference between the Number of enrolments of both sexes of High income: OECD and Number of enrolments of both sexes of Dominican Republic?
Give a very brief answer. 1.42e+07. In the year 1977, what is the difference between the Number of enrolments of both sexes in High income: OECD and Number of enrolments of both sexes in Korea (Republic)?
Give a very brief answer. 1.37e+07. In the year 1977, what is the difference between the Number of enrolments of both sexes of High income: OECD and Number of enrolments of both sexes of Swaziland?
Ensure brevity in your answer.  1.42e+07. In the year 1977, what is the difference between the Number of enrolments of both sexes in Dominican Republic and Number of enrolments of both sexes in Korea (Republic)?
Provide a succinct answer. -4.38e+05. In the year 1977, what is the difference between the Number of enrolments of both sexes in Dominican Republic and Number of enrolments of both sexes in Swaziland?
Provide a succinct answer. 2.07e+04. In the year 1977, what is the difference between the Number of enrolments of both sexes of Korea (Republic) and Number of enrolments of both sexes of Swaziland?
Ensure brevity in your answer.  4.59e+05. In the year 1978, what is the difference between the Number of enrolments of both sexes of High income: OECD and Number of enrolments of both sexes of Dominican Republic?
Offer a very short reply. 1.44e+07. In the year 1978, what is the difference between the Number of enrolments of both sexes of High income: OECD and Number of enrolments of both sexes of Korea (Republic)?
Your answer should be very brief. 1.39e+07. In the year 1978, what is the difference between the Number of enrolments of both sexes of High income: OECD and Number of enrolments of both sexes of Swaziland?
Provide a short and direct response. 1.44e+07. In the year 1978, what is the difference between the Number of enrolments of both sexes of Dominican Republic and Number of enrolments of both sexes of Korea (Republic)?
Offer a very short reply. -4.80e+05. In the year 1978, what is the difference between the Number of enrolments of both sexes of Dominican Republic and Number of enrolments of both sexes of Swaziland?
Make the answer very short. 2.09e+04. In the year 1978, what is the difference between the Number of enrolments of both sexes in Korea (Republic) and Number of enrolments of both sexes in Swaziland?
Offer a terse response. 5.01e+05. What is the ratio of the Number of enrolments of both sexes in High income: OECD in 1971 to that in 1972?
Provide a short and direct response. 0.97. What is the ratio of the Number of enrolments of both sexes of Dominican Republic in 1971 to that in 1972?
Your answer should be compact. 0.89. What is the ratio of the Number of enrolments of both sexes of Korea (Republic) in 1971 to that in 1972?
Offer a very short reply. 0.9. What is the ratio of the Number of enrolments of both sexes of Swaziland in 1971 to that in 1972?
Provide a short and direct response. 0.88. What is the ratio of the Number of enrolments of both sexes of High income: OECD in 1971 to that in 1973?
Your answer should be very brief. 0.96. What is the ratio of the Number of enrolments of both sexes in Dominican Republic in 1971 to that in 1973?
Make the answer very short. 0.86. What is the ratio of the Number of enrolments of both sexes of Korea (Republic) in 1971 to that in 1973?
Give a very brief answer. 0.8. What is the ratio of the Number of enrolments of both sexes in Swaziland in 1971 to that in 1973?
Your answer should be compact. 0.81. What is the ratio of the Number of enrolments of both sexes of High income: OECD in 1971 to that in 1974?
Your response must be concise. 0.94. What is the ratio of the Number of enrolments of both sexes in Dominican Republic in 1971 to that in 1974?
Your response must be concise. 0.73. What is the ratio of the Number of enrolments of both sexes of Korea (Republic) in 1971 to that in 1974?
Offer a terse response. 0.67. What is the ratio of the Number of enrolments of both sexes in Swaziland in 1971 to that in 1974?
Provide a succinct answer. 0.71. What is the ratio of the Number of enrolments of both sexes of High income: OECD in 1971 to that in 1975?
Your response must be concise. 0.93. What is the ratio of the Number of enrolments of both sexes in Dominican Republic in 1971 to that in 1975?
Make the answer very short. 0.64. What is the ratio of the Number of enrolments of both sexes of Korea (Republic) in 1971 to that in 1975?
Keep it short and to the point. 0.65. What is the ratio of the Number of enrolments of both sexes of Swaziland in 1971 to that in 1975?
Provide a succinct answer. 0.73. What is the ratio of the Number of enrolments of both sexes of High income: OECD in 1971 to that in 1976?
Give a very brief answer. 0.91. What is the ratio of the Number of enrolments of both sexes in Dominican Republic in 1971 to that in 1976?
Your answer should be compact. 0.61. What is the ratio of the Number of enrolments of both sexes in Korea (Republic) in 1971 to that in 1976?
Your answer should be very brief. 0.62. What is the ratio of the Number of enrolments of both sexes in Swaziland in 1971 to that in 1976?
Your answer should be compact. 1. What is the ratio of the Number of enrolments of both sexes in High income: OECD in 1971 to that in 1977?
Your answer should be compact. 0.89. What is the ratio of the Number of enrolments of both sexes of Dominican Republic in 1971 to that in 1977?
Offer a very short reply. 0.6. What is the ratio of the Number of enrolments of both sexes of Korea (Republic) in 1971 to that in 1977?
Ensure brevity in your answer.  0.59. What is the ratio of the Number of enrolments of both sexes of Swaziland in 1971 to that in 1977?
Offer a very short reply. 1.18. What is the ratio of the Number of enrolments of both sexes of High income: OECD in 1971 to that in 1978?
Offer a terse response. 0.88. What is the ratio of the Number of enrolments of both sexes in Dominican Republic in 1971 to that in 1978?
Ensure brevity in your answer.  0.59. What is the ratio of the Number of enrolments of both sexes of Korea (Republic) in 1971 to that in 1978?
Your response must be concise. 0.54. What is the ratio of the Number of enrolments of both sexes of Swaziland in 1971 to that in 1978?
Provide a short and direct response. 1.17. What is the ratio of the Number of enrolments of both sexes in High income: OECD in 1972 to that in 1973?
Provide a short and direct response. 0.98. What is the ratio of the Number of enrolments of both sexes in Dominican Republic in 1972 to that in 1973?
Your answer should be compact. 0.97. What is the ratio of the Number of enrolments of both sexes in Korea (Republic) in 1972 to that in 1973?
Offer a terse response. 0.88. What is the ratio of the Number of enrolments of both sexes in Swaziland in 1972 to that in 1973?
Your response must be concise. 0.92. What is the ratio of the Number of enrolments of both sexes in High income: OECD in 1972 to that in 1974?
Provide a succinct answer. 0.96. What is the ratio of the Number of enrolments of both sexes in Dominican Republic in 1972 to that in 1974?
Provide a short and direct response. 0.82. What is the ratio of the Number of enrolments of both sexes in Korea (Republic) in 1972 to that in 1974?
Offer a terse response. 0.75. What is the ratio of the Number of enrolments of both sexes of Swaziland in 1972 to that in 1974?
Give a very brief answer. 0.81. What is the ratio of the Number of enrolments of both sexes of High income: OECD in 1972 to that in 1975?
Provide a short and direct response. 0.96. What is the ratio of the Number of enrolments of both sexes of Dominican Republic in 1972 to that in 1975?
Offer a terse response. 0.72. What is the ratio of the Number of enrolments of both sexes of Korea (Republic) in 1972 to that in 1975?
Provide a short and direct response. 0.72. What is the ratio of the Number of enrolments of both sexes of Swaziland in 1972 to that in 1975?
Provide a short and direct response. 0.83. What is the ratio of the Number of enrolments of both sexes of High income: OECD in 1972 to that in 1976?
Your answer should be compact. 0.93. What is the ratio of the Number of enrolments of both sexes of Dominican Republic in 1972 to that in 1976?
Give a very brief answer. 0.69. What is the ratio of the Number of enrolments of both sexes of Korea (Republic) in 1972 to that in 1976?
Provide a succinct answer. 0.69. What is the ratio of the Number of enrolments of both sexes of Swaziland in 1972 to that in 1976?
Offer a very short reply. 1.14. What is the ratio of the Number of enrolments of both sexes of High income: OECD in 1972 to that in 1977?
Give a very brief answer. 0.91. What is the ratio of the Number of enrolments of both sexes of Dominican Republic in 1972 to that in 1977?
Give a very brief answer. 0.68. What is the ratio of the Number of enrolments of both sexes of Korea (Republic) in 1972 to that in 1977?
Your answer should be very brief. 0.66. What is the ratio of the Number of enrolments of both sexes in Swaziland in 1972 to that in 1977?
Your answer should be very brief. 1.33. What is the ratio of the Number of enrolments of both sexes of High income: OECD in 1972 to that in 1978?
Your answer should be very brief. 0.9. What is the ratio of the Number of enrolments of both sexes in Dominican Republic in 1972 to that in 1978?
Make the answer very short. 0.67. What is the ratio of the Number of enrolments of both sexes in Korea (Republic) in 1972 to that in 1978?
Provide a succinct answer. 0.6. What is the ratio of the Number of enrolments of both sexes of Swaziland in 1972 to that in 1978?
Provide a short and direct response. 1.33. What is the ratio of the Number of enrolments of both sexes of High income: OECD in 1973 to that in 1974?
Offer a terse response. 0.98. What is the ratio of the Number of enrolments of both sexes in Dominican Republic in 1973 to that in 1974?
Your answer should be compact. 0.84. What is the ratio of the Number of enrolments of both sexes in Korea (Republic) in 1973 to that in 1974?
Your answer should be compact. 0.84. What is the ratio of the Number of enrolments of both sexes in Swaziland in 1973 to that in 1974?
Your answer should be very brief. 0.88. What is the ratio of the Number of enrolments of both sexes of High income: OECD in 1973 to that in 1975?
Offer a very short reply. 0.98. What is the ratio of the Number of enrolments of both sexes in Dominican Republic in 1973 to that in 1975?
Provide a short and direct response. 0.74. What is the ratio of the Number of enrolments of both sexes of Korea (Republic) in 1973 to that in 1975?
Give a very brief answer. 0.81. What is the ratio of the Number of enrolments of both sexes in Swaziland in 1973 to that in 1975?
Offer a very short reply. 0.9. What is the ratio of the Number of enrolments of both sexes in High income: OECD in 1973 to that in 1976?
Provide a succinct answer. 0.95. What is the ratio of the Number of enrolments of both sexes of Dominican Republic in 1973 to that in 1976?
Offer a terse response. 0.71. What is the ratio of the Number of enrolments of both sexes in Korea (Republic) in 1973 to that in 1976?
Offer a very short reply. 0.78. What is the ratio of the Number of enrolments of both sexes in Swaziland in 1973 to that in 1976?
Offer a very short reply. 1.24. What is the ratio of the Number of enrolments of both sexes of High income: OECD in 1973 to that in 1977?
Offer a very short reply. 0.93. What is the ratio of the Number of enrolments of both sexes in Dominican Republic in 1973 to that in 1977?
Provide a short and direct response. 0.69. What is the ratio of the Number of enrolments of both sexes in Korea (Republic) in 1973 to that in 1977?
Provide a succinct answer. 0.74. What is the ratio of the Number of enrolments of both sexes in Swaziland in 1973 to that in 1977?
Give a very brief answer. 1.45. What is the ratio of the Number of enrolments of both sexes of High income: OECD in 1973 to that in 1978?
Make the answer very short. 0.92. What is the ratio of the Number of enrolments of both sexes of Dominican Republic in 1973 to that in 1978?
Offer a terse response. 0.69. What is the ratio of the Number of enrolments of both sexes in Korea (Republic) in 1973 to that in 1978?
Your answer should be very brief. 0.68. What is the ratio of the Number of enrolments of both sexes of Swaziland in 1973 to that in 1978?
Make the answer very short. 1.44. What is the ratio of the Number of enrolments of both sexes in High income: OECD in 1974 to that in 1975?
Provide a succinct answer. 1. What is the ratio of the Number of enrolments of both sexes of Dominican Republic in 1974 to that in 1975?
Ensure brevity in your answer.  0.87. What is the ratio of the Number of enrolments of both sexes of Korea (Republic) in 1974 to that in 1975?
Your answer should be very brief. 0.96. What is the ratio of the Number of enrolments of both sexes of Swaziland in 1974 to that in 1975?
Provide a short and direct response. 1.02. What is the ratio of the Number of enrolments of both sexes in High income: OECD in 1974 to that in 1976?
Your response must be concise. 0.97. What is the ratio of the Number of enrolments of both sexes in Dominican Republic in 1974 to that in 1976?
Offer a very short reply. 0.84. What is the ratio of the Number of enrolments of both sexes in Korea (Republic) in 1974 to that in 1976?
Ensure brevity in your answer.  0.93. What is the ratio of the Number of enrolments of both sexes in Swaziland in 1974 to that in 1976?
Your answer should be compact. 1.4. What is the ratio of the Number of enrolments of both sexes in High income: OECD in 1974 to that in 1977?
Make the answer very short. 0.95. What is the ratio of the Number of enrolments of both sexes in Dominican Republic in 1974 to that in 1977?
Keep it short and to the point. 0.82. What is the ratio of the Number of enrolments of both sexes of Korea (Republic) in 1974 to that in 1977?
Ensure brevity in your answer.  0.88. What is the ratio of the Number of enrolments of both sexes in Swaziland in 1974 to that in 1977?
Give a very brief answer. 1.65. What is the ratio of the Number of enrolments of both sexes of High income: OECD in 1974 to that in 1978?
Provide a short and direct response. 0.93. What is the ratio of the Number of enrolments of both sexes in Dominican Republic in 1974 to that in 1978?
Ensure brevity in your answer.  0.82. What is the ratio of the Number of enrolments of both sexes of Korea (Republic) in 1974 to that in 1978?
Make the answer very short. 0.81. What is the ratio of the Number of enrolments of both sexes of Swaziland in 1974 to that in 1978?
Offer a very short reply. 1.63. What is the ratio of the Number of enrolments of both sexes in High income: OECD in 1975 to that in 1976?
Your answer should be compact. 0.97. What is the ratio of the Number of enrolments of both sexes of Dominican Republic in 1975 to that in 1976?
Your answer should be very brief. 0.96. What is the ratio of the Number of enrolments of both sexes of Korea (Republic) in 1975 to that in 1976?
Provide a succinct answer. 0.96. What is the ratio of the Number of enrolments of both sexes in Swaziland in 1975 to that in 1976?
Offer a very short reply. 1.38. What is the ratio of the Number of enrolments of both sexes of High income: OECD in 1975 to that in 1977?
Provide a succinct answer. 0.95. What is the ratio of the Number of enrolments of both sexes of Dominican Republic in 1975 to that in 1977?
Give a very brief answer. 0.94. What is the ratio of the Number of enrolments of both sexes of Korea (Republic) in 1975 to that in 1977?
Your response must be concise. 0.91. What is the ratio of the Number of enrolments of both sexes in Swaziland in 1975 to that in 1977?
Your answer should be very brief. 1.61. What is the ratio of the Number of enrolments of both sexes of High income: OECD in 1975 to that in 1978?
Give a very brief answer. 0.94. What is the ratio of the Number of enrolments of both sexes of Dominican Republic in 1975 to that in 1978?
Your answer should be compact. 0.93. What is the ratio of the Number of enrolments of both sexes of Korea (Republic) in 1975 to that in 1978?
Give a very brief answer. 0.84. What is the ratio of the Number of enrolments of both sexes in Swaziland in 1975 to that in 1978?
Offer a terse response. 1.6. What is the ratio of the Number of enrolments of both sexes of High income: OECD in 1976 to that in 1977?
Provide a short and direct response. 0.98. What is the ratio of the Number of enrolments of both sexes of Dominican Republic in 1976 to that in 1977?
Offer a very short reply. 0.98. What is the ratio of the Number of enrolments of both sexes of Korea (Republic) in 1976 to that in 1977?
Your answer should be very brief. 0.95. What is the ratio of the Number of enrolments of both sexes in Swaziland in 1976 to that in 1977?
Keep it short and to the point. 1.17. What is the ratio of the Number of enrolments of both sexes in High income: OECD in 1976 to that in 1978?
Provide a short and direct response. 0.97. What is the ratio of the Number of enrolments of both sexes of Dominican Republic in 1976 to that in 1978?
Your response must be concise. 0.97. What is the ratio of the Number of enrolments of both sexes of Korea (Republic) in 1976 to that in 1978?
Give a very brief answer. 0.87. What is the ratio of the Number of enrolments of both sexes of Swaziland in 1976 to that in 1978?
Ensure brevity in your answer.  1.16. What is the ratio of the Number of enrolments of both sexes in Dominican Republic in 1977 to that in 1978?
Make the answer very short. 0.99. What is the ratio of the Number of enrolments of both sexes of Korea (Republic) in 1977 to that in 1978?
Offer a terse response. 0.92. What is the ratio of the Number of enrolments of both sexes of Swaziland in 1977 to that in 1978?
Offer a terse response. 0.99. What is the difference between the highest and the second highest Number of enrolments of both sexes of High income: OECD?
Make the answer very short. 1.88e+05. What is the difference between the highest and the second highest Number of enrolments of both sexes in Dominican Republic?
Your answer should be very brief. 198. What is the difference between the highest and the second highest Number of enrolments of both sexes in Korea (Republic)?
Your answer should be compact. 4.21e+04. What is the difference between the highest and the lowest Number of enrolments of both sexes in High income: OECD?
Provide a succinct answer. 1.78e+06. What is the difference between the highest and the lowest Number of enrolments of both sexes of Dominican Republic?
Keep it short and to the point. 8672. What is the difference between the highest and the lowest Number of enrolments of both sexes in Korea (Republic)?
Your response must be concise. 2.28e+05. What is the difference between the highest and the lowest Number of enrolments of both sexes of Swaziland?
Provide a succinct answer. 260. 